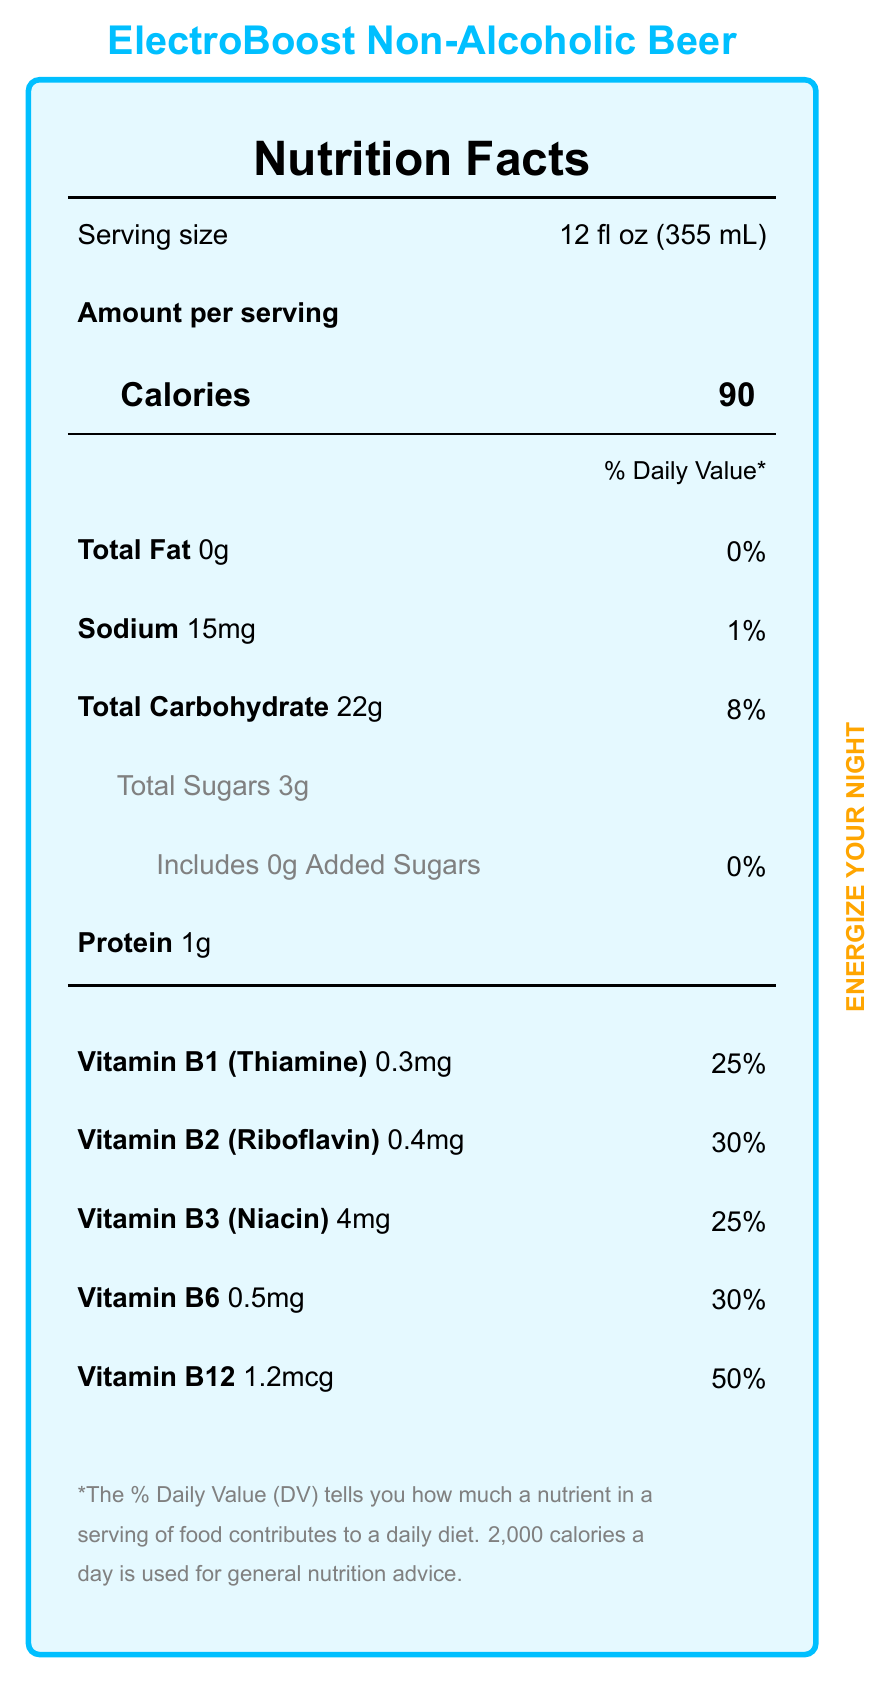what is the serving size of ElectroBoost Non-Alcoholic Beer? The serving size is listed as "12 fl oz (355 mL)" on the document.
Answer: 12 fl oz (355 mL) how many calories are in one serving of ElectroBoost Non-Alcoholic Beer? The document states that there are 90 calories per serving.
Answer: 90 what is the percentage of daily value for sodium in one serving? The daily value percentage for sodium is indicated as 1% on the document.
Answer: 1% how much protein does one serving contain? The document lists that one serving contains 1g of protein.
Answer: 1g which vitamins are included in ElectroBoost Non-Alcoholic Beer? The document lists these vitamins under the nutrition facts: Vitamin B1 (Thiamine), Vitamin B2 (Riboflavin), Vitamin B3 (Niacin), Vitamin B6, and Vitamin B12.
Answer: Vitamin B1 (Thiamine), Vitamin B2 (Riboflavin), Vitamin B3 (Niacin), Vitamin B6, Vitamin B12 how much vitamin B1 (Thiamine) is in one serving, and what percentage of the daily value does it represent? The document states that one serving contains 0.3mg of Vitamin B1 (Thiamine), which is 25% of the daily value.
Answer: 0.3mg, 25% which ingredient is specifically mentioned as an allergen? The allergen information section indicates that the product contains Barley.
Answer: Barley how much added sugars are in ElectroBoost Non-Alcoholic Beer? The document indicates that there are 0g of added sugars.
Answer: 0g which statement is true about the total carbohydrate content? A. ElectroBoost has 10g of total carbohydrates. B. ElectroBoost has 22g of total carbohydrates. C. ElectroBoost has 15g of total carbohydrates. The document lists the total carbohydrate content as 22g.
Answer: B. ElectroBoost has 22g of total carbohydrates. what is the Correct percentage of daily value for vitamin B12 in one serving? A. 25% B. 30% C. 50% D. 100% The daily value percentage for vitamin B12 is 50%, as indicated by the document.
Answer: C. 50% is the product ElectroBoost Non-Alcoholic Beer brewed using renewable energy? The sustainability note mentions that the product is brewed using 100% renewable energy.
Answer: Yes summarize the main idea of the document. The document provides detailed nutrition facts and highlights that ElectroBoost Non-Alcoholic Beer is designed for energy during music events, enriched with B-vitamins, with sustainability in mind and also sponsors a music festival.
Answer: ElectroBoost Non-Alcoholic Beer is a refreshing beverage enriched with B-vitamins, providing sustained energy for long electronic music events. The nutrition facts highlight the low calorie, low fat, and high vitamin content, making it a healthy alternative. The drink is brewed using renewable energy and contains barley as an allergen. It is the official beverage sponsor of TechnoFest 2023. what other events does ElectroBoost sponsor besides TechnoFest 2023? The document only mentions TechnoFest 2023 as the sponsored event.
Answer: Not enough information 